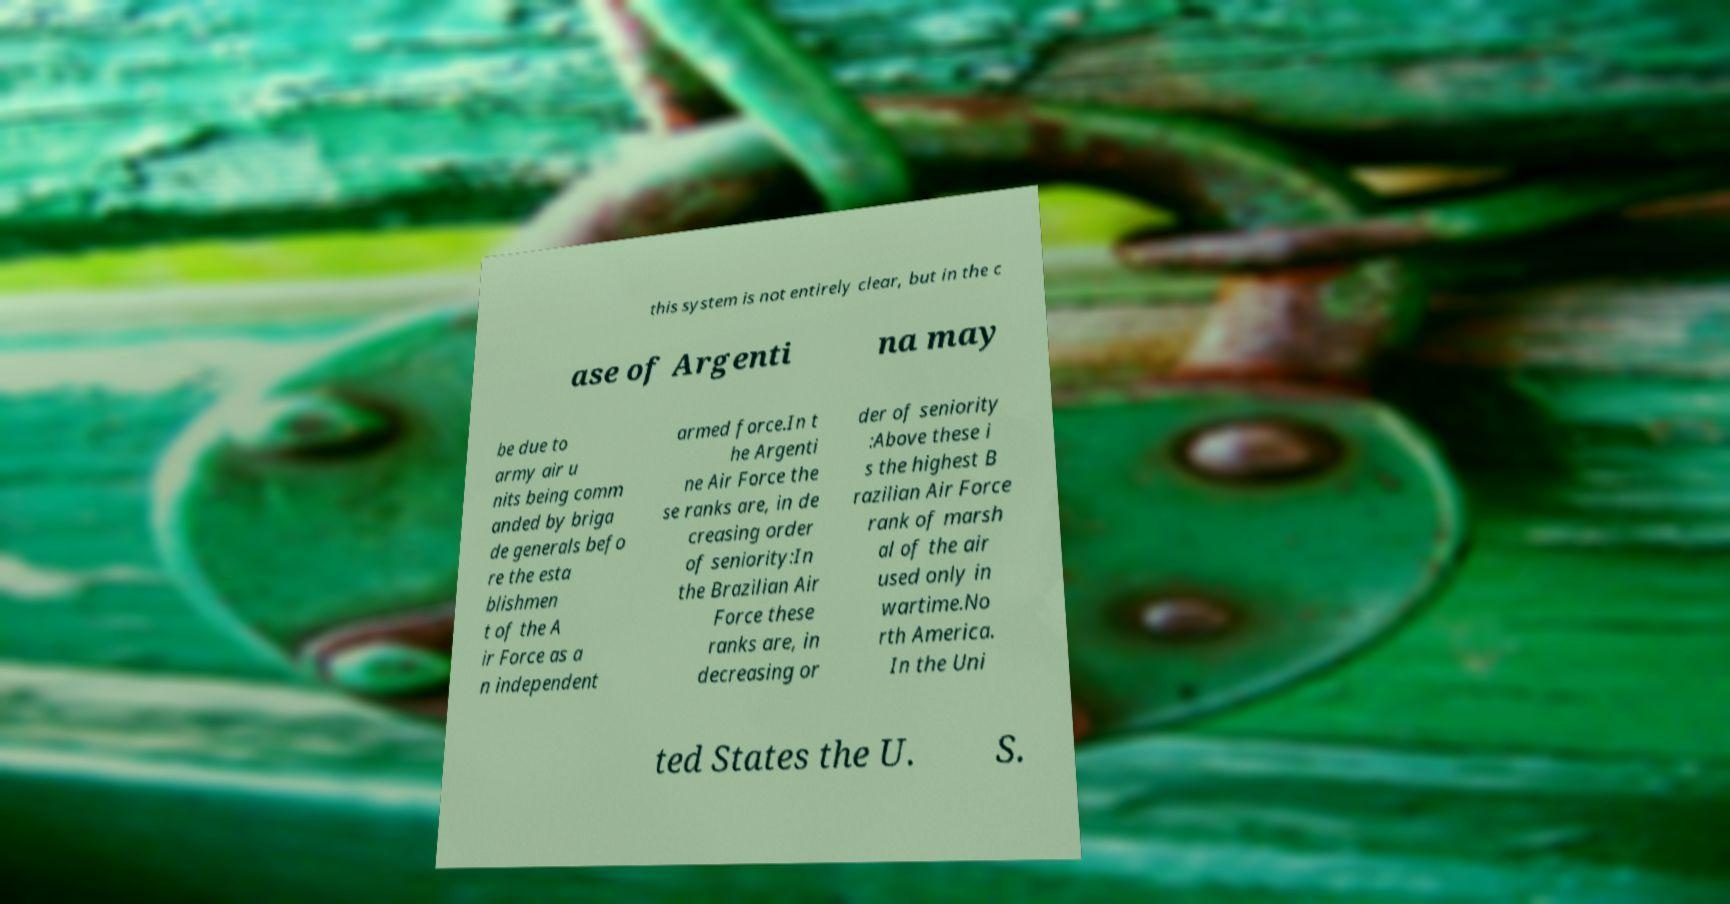Could you assist in decoding the text presented in this image and type it out clearly? this system is not entirely clear, but in the c ase of Argenti na may be due to army air u nits being comm anded by briga de generals befo re the esta blishmen t of the A ir Force as a n independent armed force.In t he Argenti ne Air Force the se ranks are, in de creasing order of seniority:In the Brazilian Air Force these ranks are, in decreasing or der of seniority :Above these i s the highest B razilian Air Force rank of marsh al of the air used only in wartime.No rth America. In the Uni ted States the U. S. 